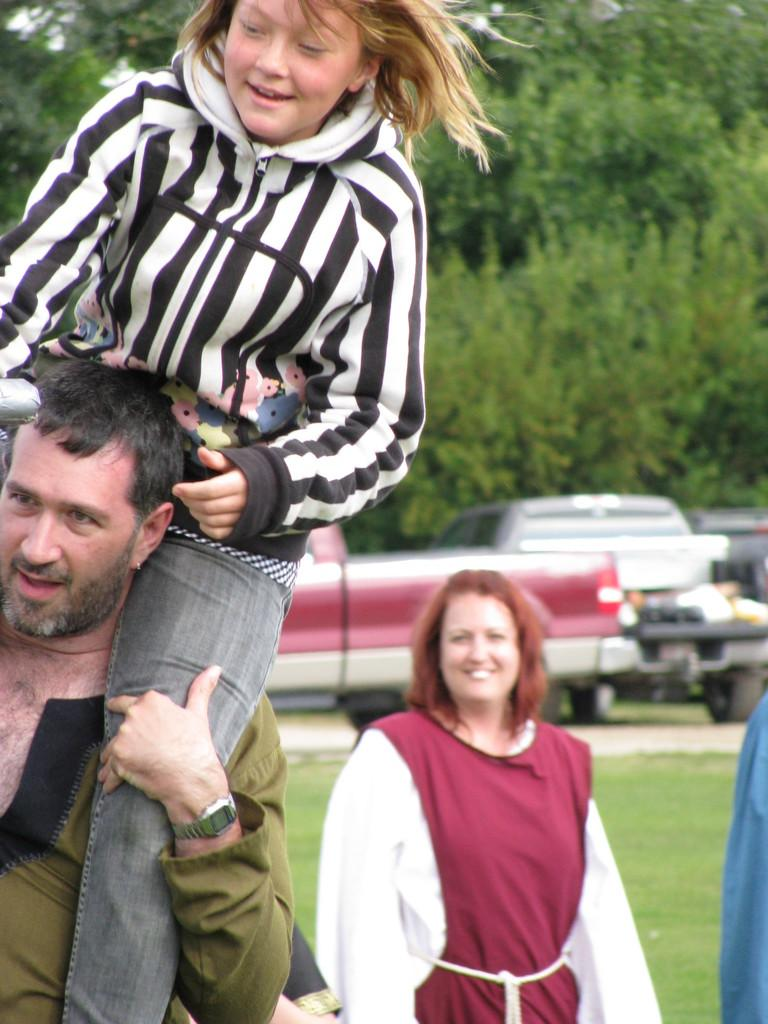What is happening in the foreground of the image? There is a man carrying a girl on his shoulders in the foreground of the image. What can be seen in the background of the image? There are vehicles, other people, grassland, and trees in the background of the image. What type of insect can be seen crawling on the girl's hair in the image? There is no insect visible on the girl's hair in the image. What kind of cat is sitting next to the man in the image? There is no cat present in the image. 